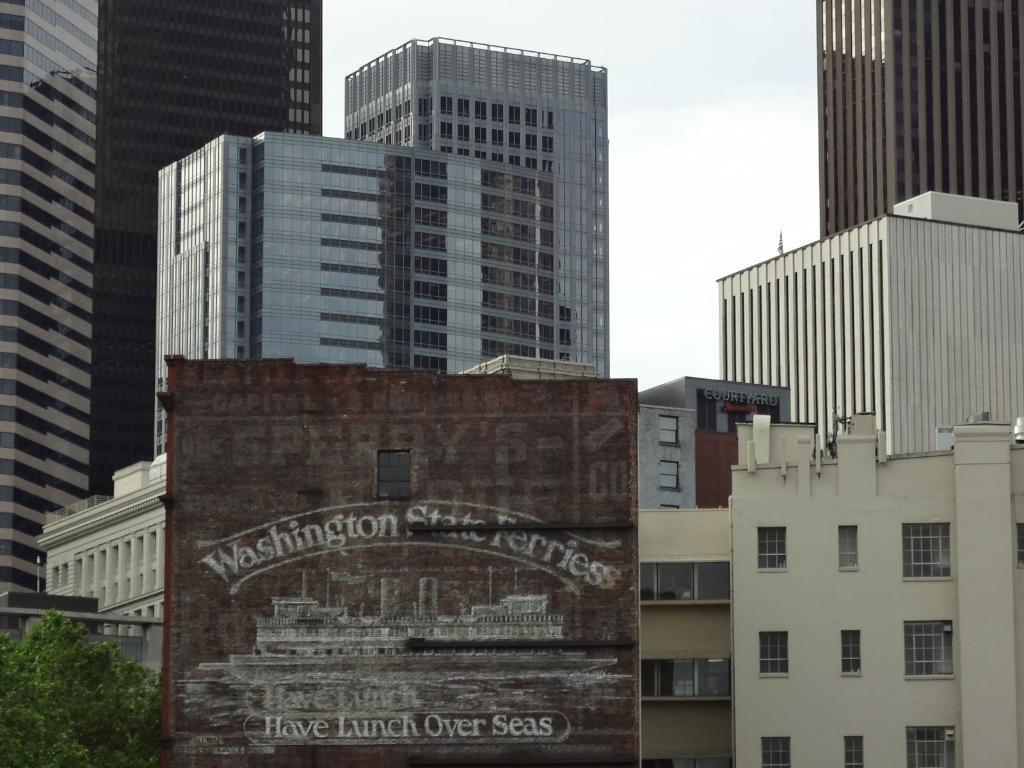Please provide a concise description of this image. In the center of the image there is a board. Beside the board there is a tree. In the background of the image there are buildings and sky. 